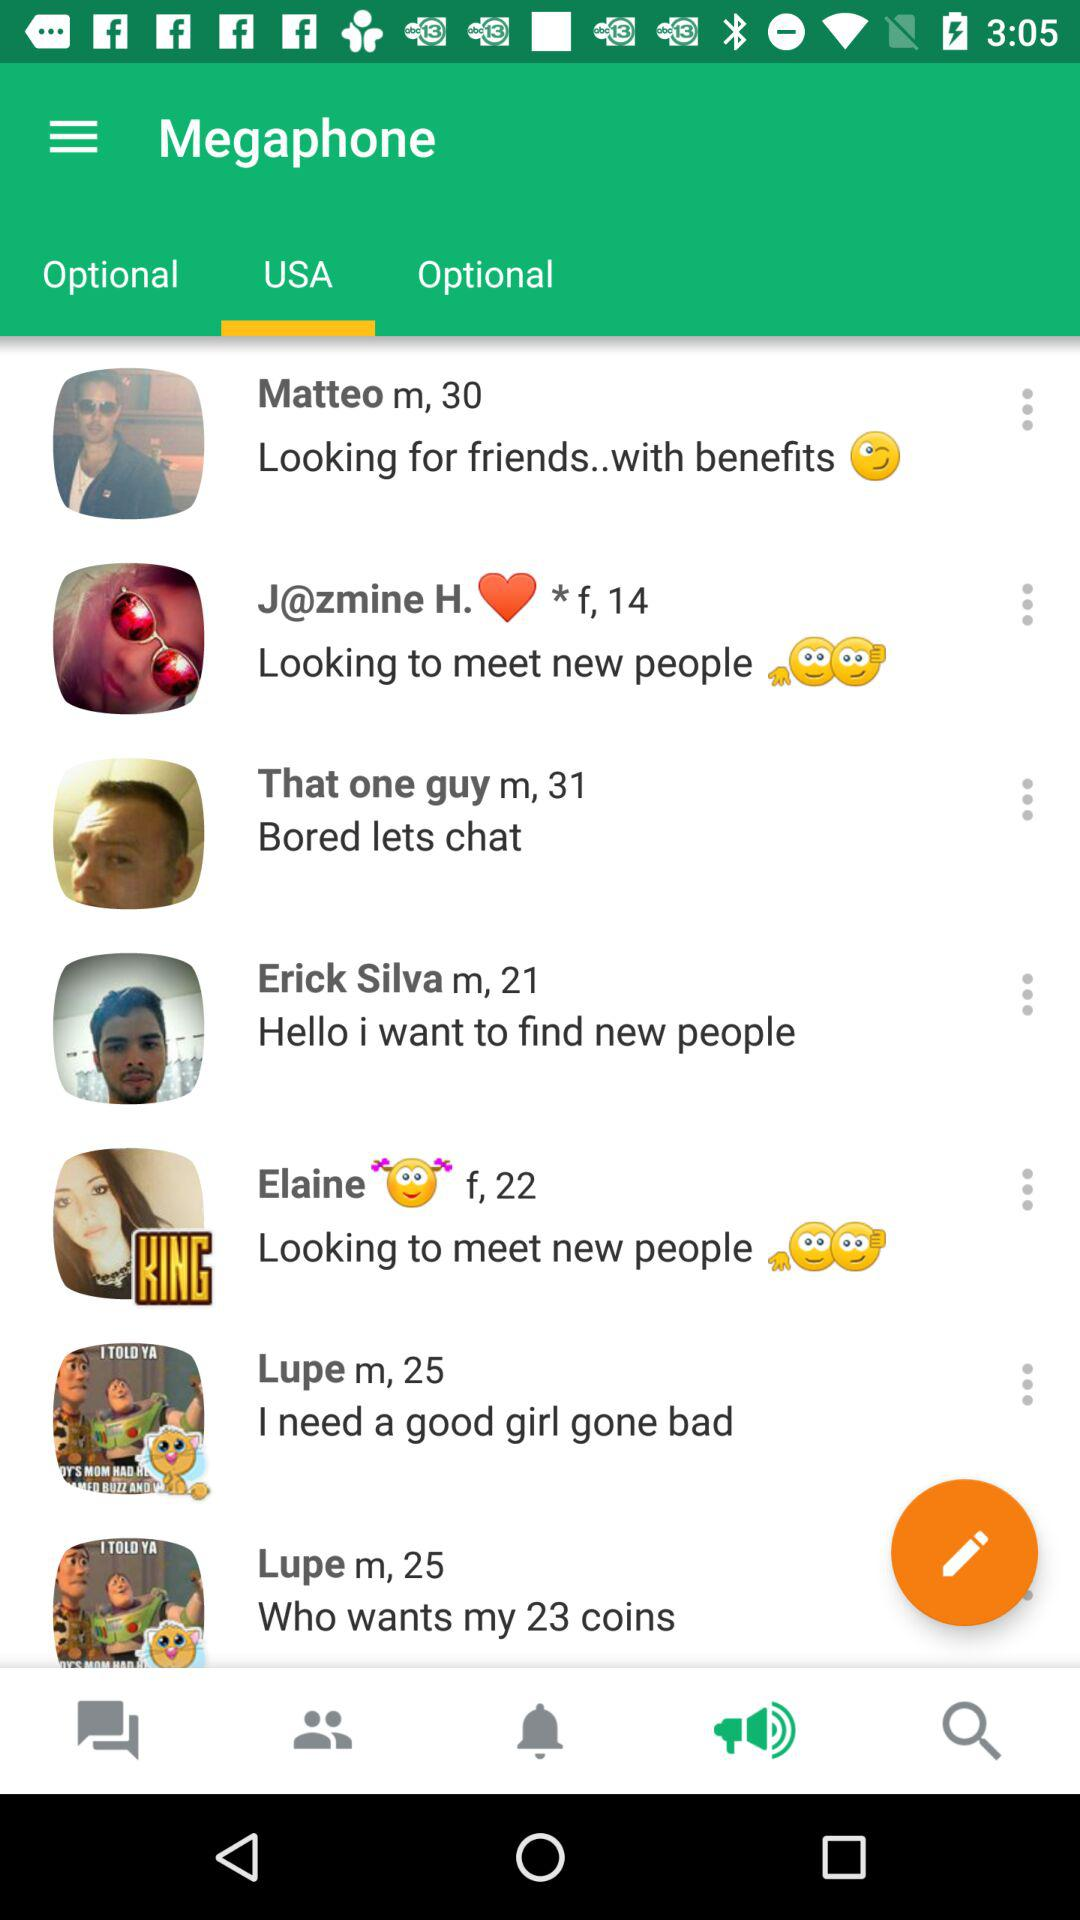What is the age of Matteo? Matteo is 30 years old. 